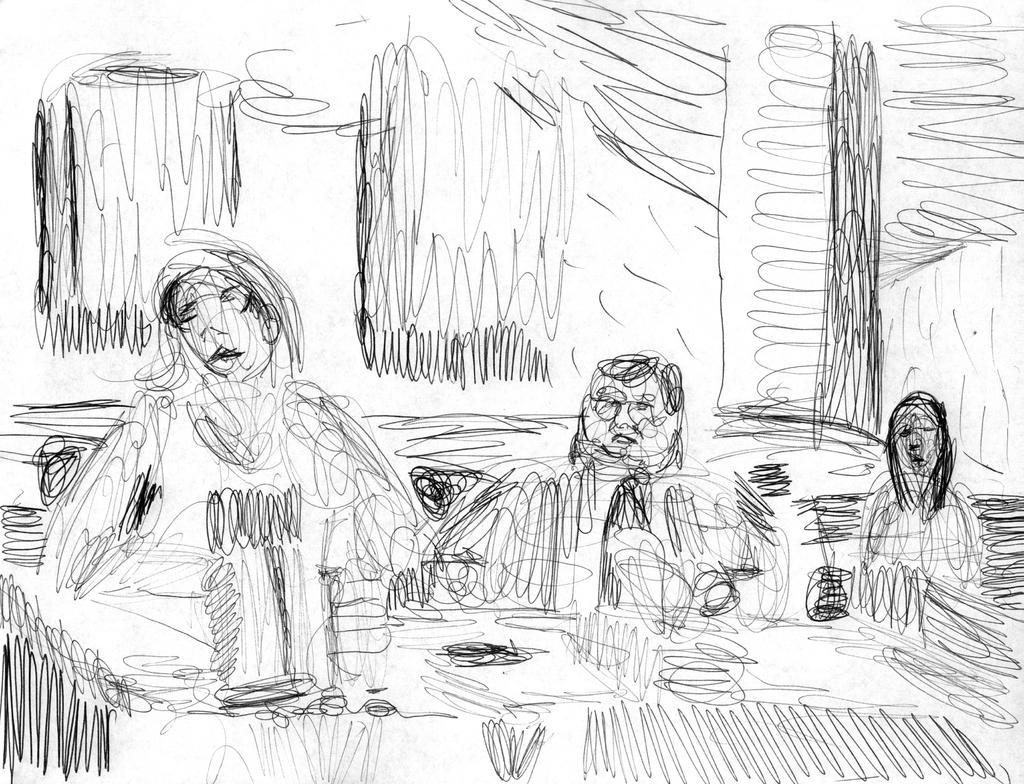In one or two sentences, can you explain what this image depicts? In the image there is are drawings of persons, windows and some other items. 